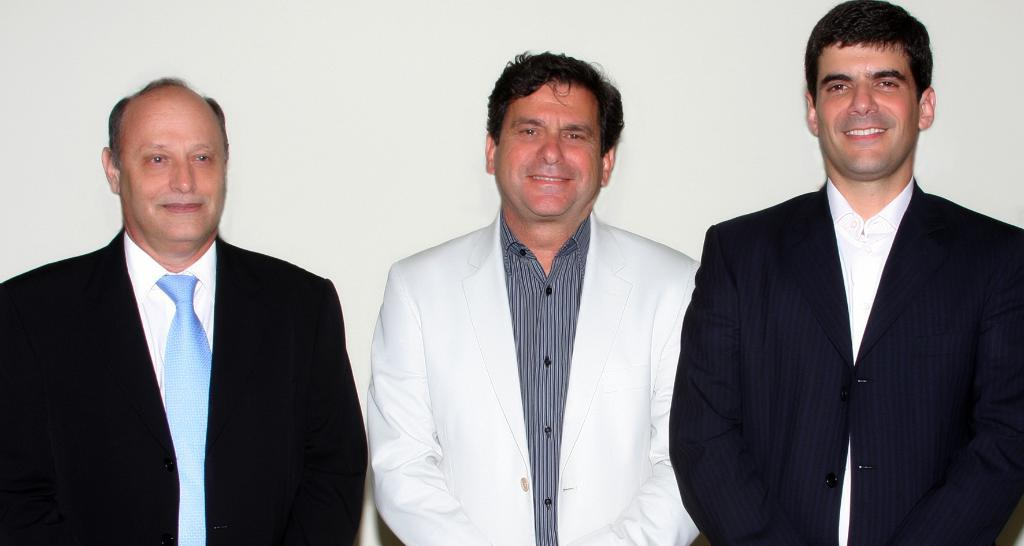How many people are in the image? There are three persons in the image. What is the facial expression of the people in the image? The persons are smiling. What can be seen in the background of the image? There is a wall in the background of the image. What type of goldfish is swimming in the image? There is no goldfish present in the image; it features three smiling persons. What color is the yarn being used by the girl in the image? There is no girl or yarn present in the image. 